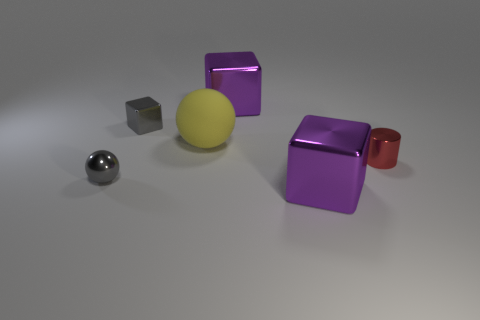There is a thing that is the same color as the small metal sphere; what is its size?
Give a very brief answer. Small. What number of other things are there of the same size as the yellow object?
Make the answer very short. 2. There is a big metal block behind the tiny gray block; what color is it?
Your answer should be very brief. Purple. Do the big object that is in front of the matte thing and the red object have the same material?
Ensure brevity in your answer.  Yes. How many things are to the left of the red object and behind the tiny ball?
Provide a short and direct response. 3. What is the color of the metal block right of the purple block on the left side of the purple cube in front of the tiny shiny block?
Keep it short and to the point. Purple. What number of other objects are there of the same shape as the rubber thing?
Provide a short and direct response. 1. Is there a big purple shiny cube that is to the left of the large purple thing that is behind the small shiny block?
Provide a succinct answer. No. How many matte objects are tiny things or tiny spheres?
Make the answer very short. 0. What material is the cube that is behind the tiny red cylinder and to the right of the yellow rubber ball?
Provide a succinct answer. Metal. 